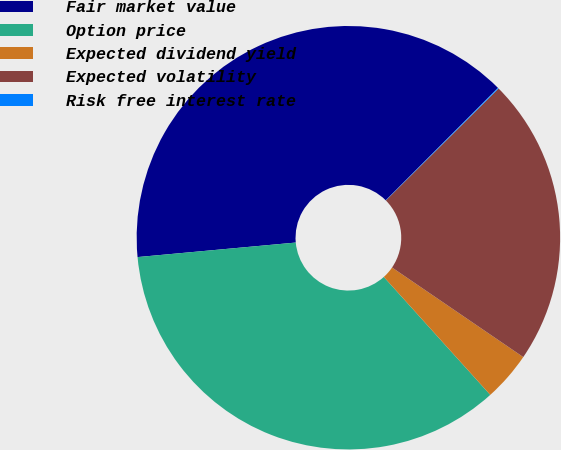<chart> <loc_0><loc_0><loc_500><loc_500><pie_chart><fcel>Fair market value<fcel>Option price<fcel>Expected dividend yield<fcel>Expected volatility<fcel>Risk free interest rate<nl><fcel>38.94%<fcel>35.23%<fcel>3.78%<fcel>21.98%<fcel>0.07%<nl></chart> 